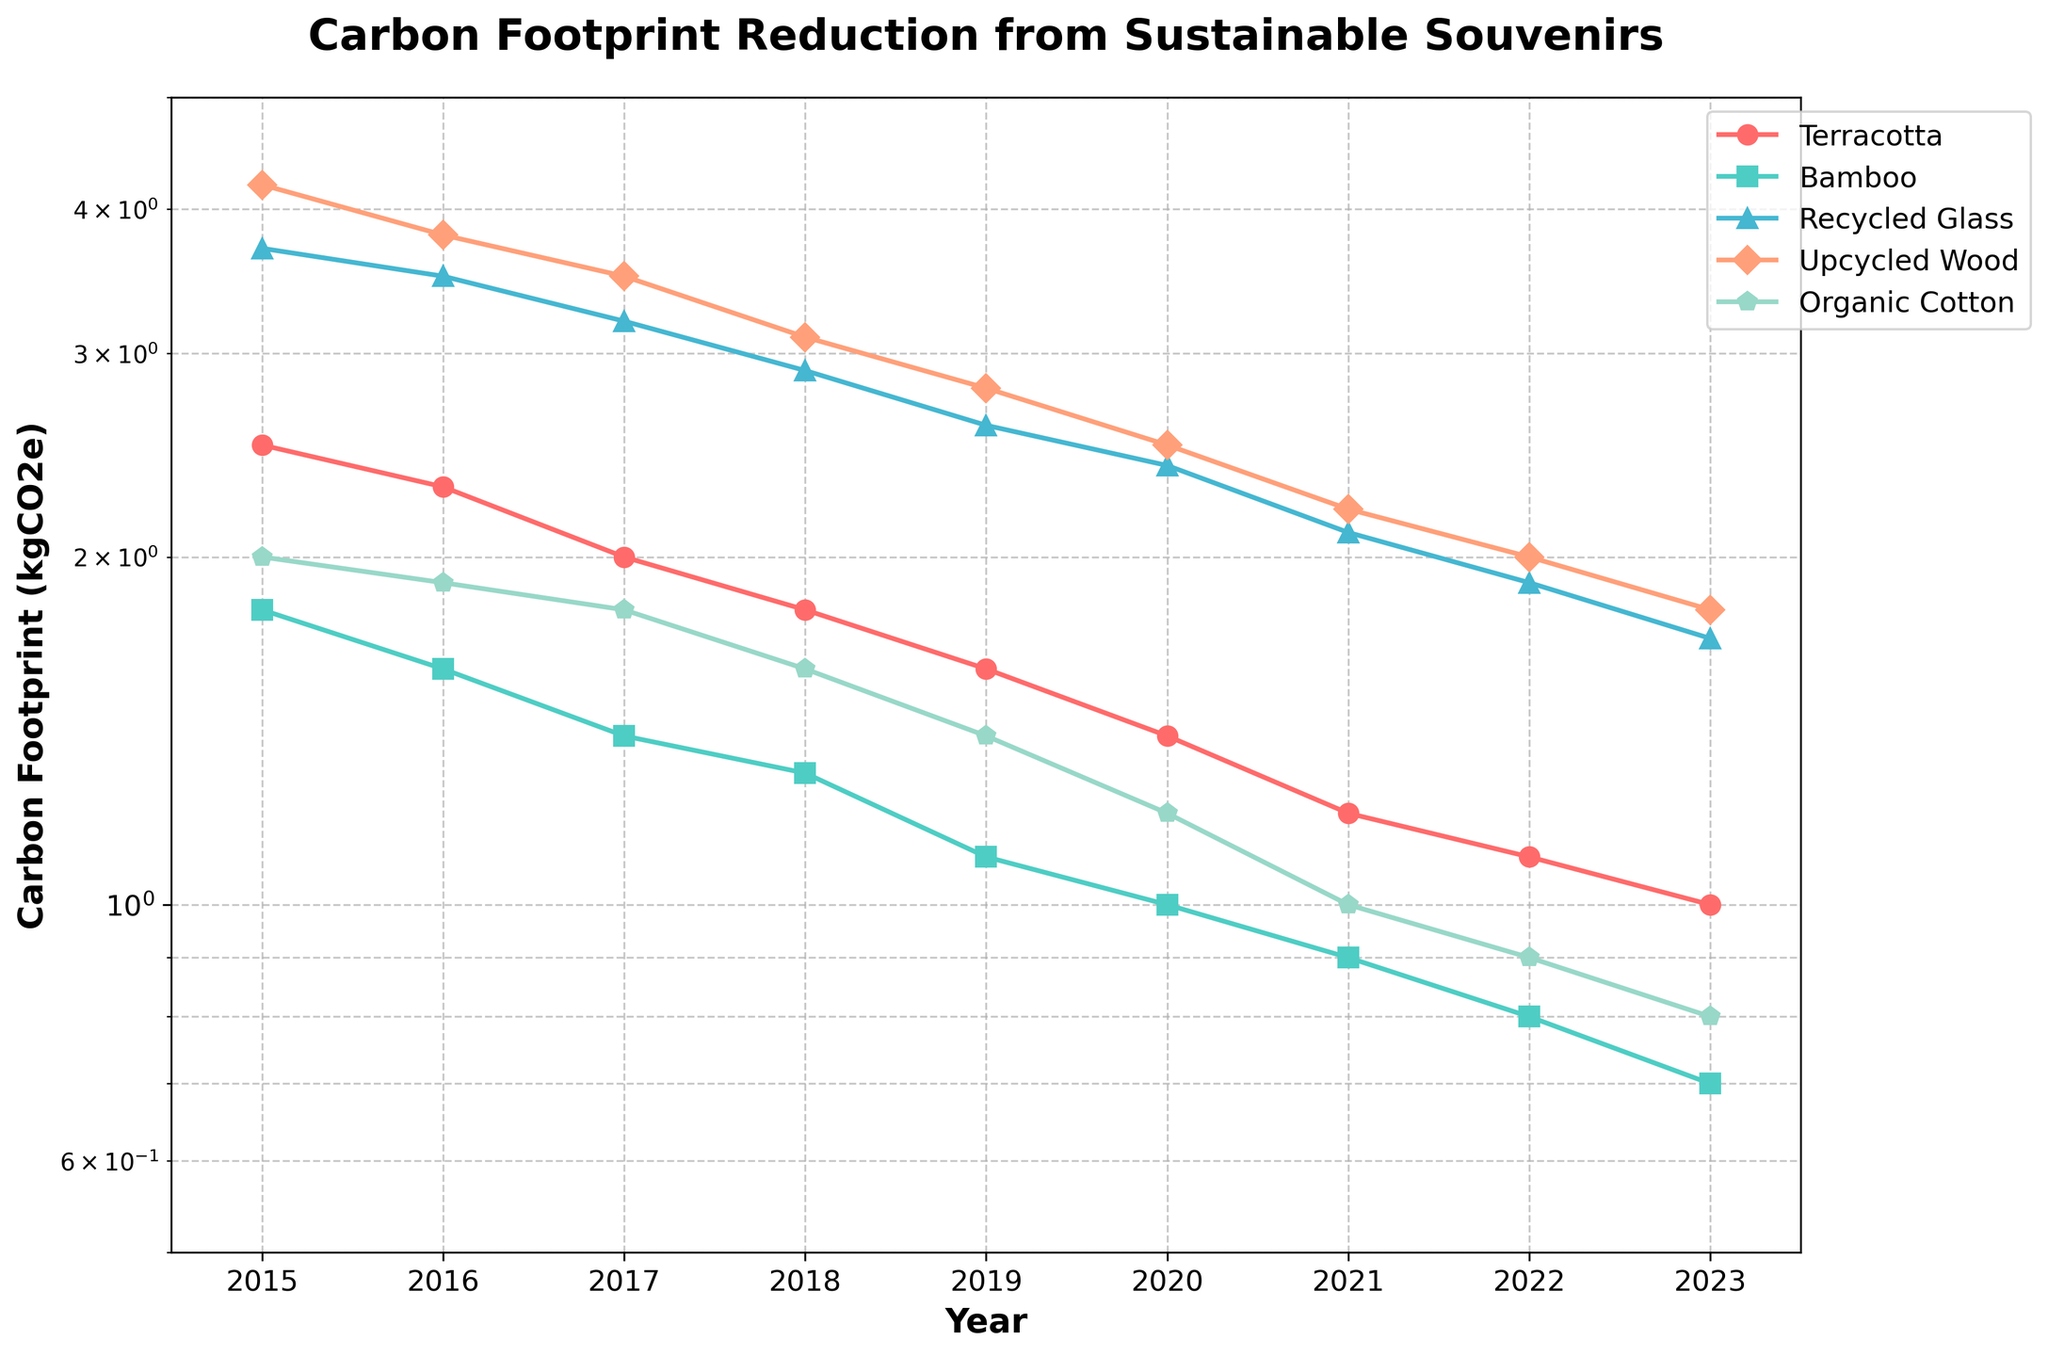What is the title of the plot? The title is at the top center of the plot and reads "Carbon Footprint Reduction from Sustainable Souvenirs".
Answer: Carbon Footprint Reduction from Sustainable Souvenirs Which material shows the lowest carbon footprint in 2023? By looking at the 2023 data points on the plot, Organic Cotton is the lowest with a value denoted by its downward trend.
Answer: Organic Cotton Between 2016 and 2018, which material showed the steepest reduction in carbon footprint? By comparing the slopes of the lines for each material between 2016 and 2018, Upcycled Wood shows the most significant decrease in carbon footprint.
Answer: Upcycled Wood What is the carbon footprint value for Terracotta in 2015? By locating the first data point for Terracotta (marked by a specific color) in 2015, the value is 2.5 kgCO2e.
Answer: 2.5 kgCO2e In which year did the carbon footprint for Bamboo first drop below 1.0 kgCO2e? By tracing the line for Bamboo and finding the first year it falls below the 1.0 kgCO2e mark on the y-axis, it occurs in 2019.
Answer: 2019 What is the overall trend in carbon footprint for Recycled Glass from 2015 to 2023? Observing the line representing Recycled Glass across the years, it consistently shows a downward trend from 3.7 kgCO2e to 1.7 kgCO2e.
Answer: Downward trend How many materials had a carbon footprint below 2.0 kgCO2e in 2021? In the year 2021, finding all the lines that are below the 2.0 kgCO2e mark, we count four materials: Bamboo, Recycled Glass, Upcycled Wood, and Organic Cotton.
Answer: Four materials Which material showed the smallest decrease in carbon footprint from 2015 to 2023? By comparing the total reduction in carbon footprint for all materials from 2015 to 2023, Organic Cotton has the smallest change from 2.0 kgCO2e to 0.8 kgCO2e.
Answer: Organic Cotton What is the carbon footprint value for Upcycled Wood in 2019 and how does it compare to the value in 2020? The value for Upcycled Wood in 2019 is 2.8 kgCO2e, and in 2020 it is 2.5 kgCO2e. The comparison shows a reduction.
Answer: 2.8 kgCO2e in 2019, reduced to 2.5 kgCO2e in 2020 What common trend can be observed for all the materials from 2015 to 2023? By examining the plot, all materials show a common downward trend in their carbon footprints over the years from 2015 to 2023.
Answer: Downward trend for all materials 